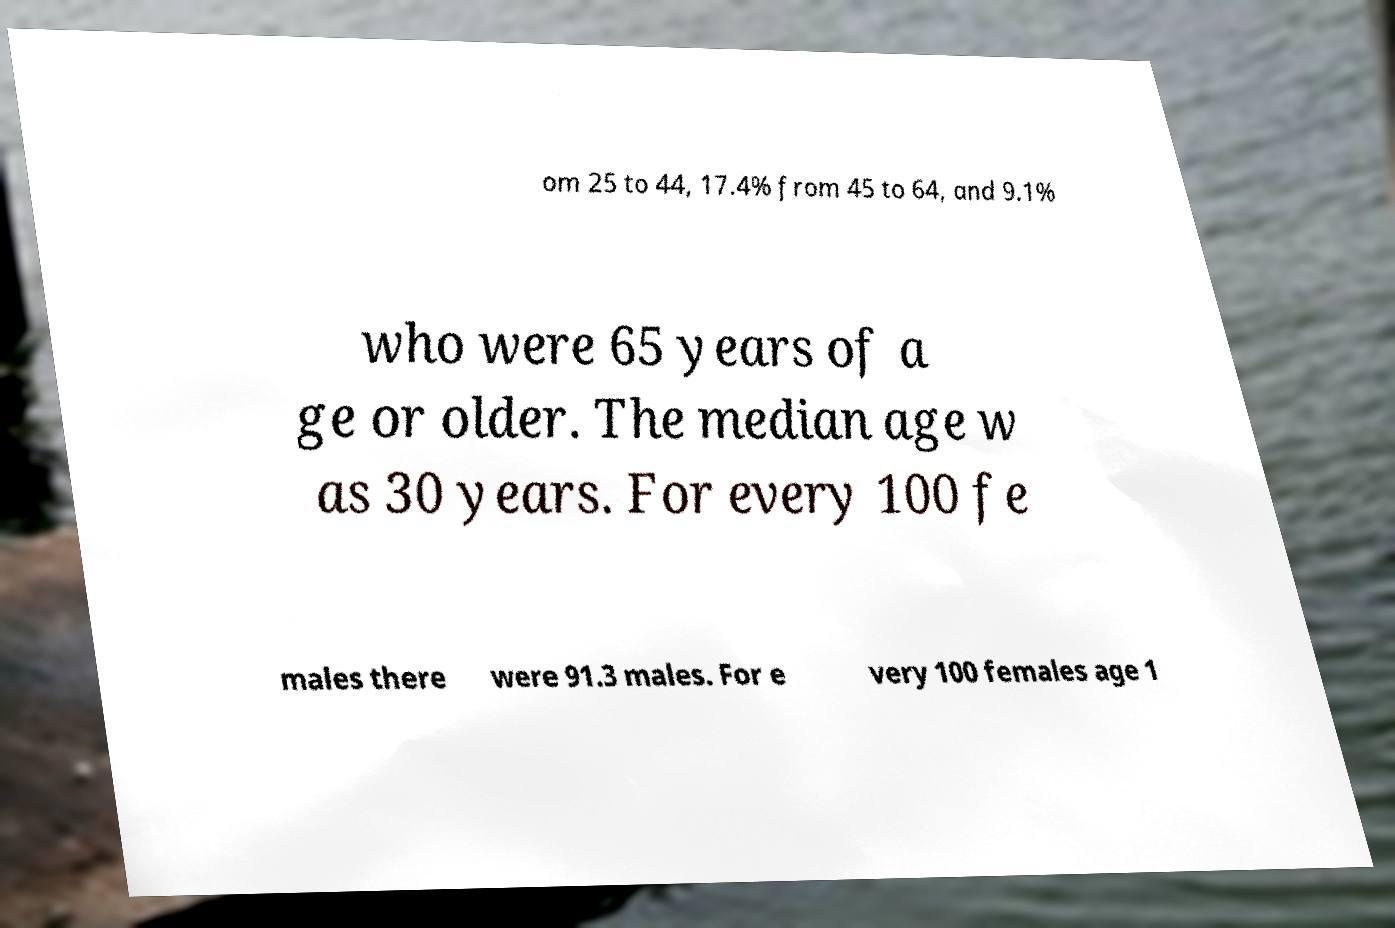Please identify and transcribe the text found in this image. om 25 to 44, 17.4% from 45 to 64, and 9.1% who were 65 years of a ge or older. The median age w as 30 years. For every 100 fe males there were 91.3 males. For e very 100 females age 1 